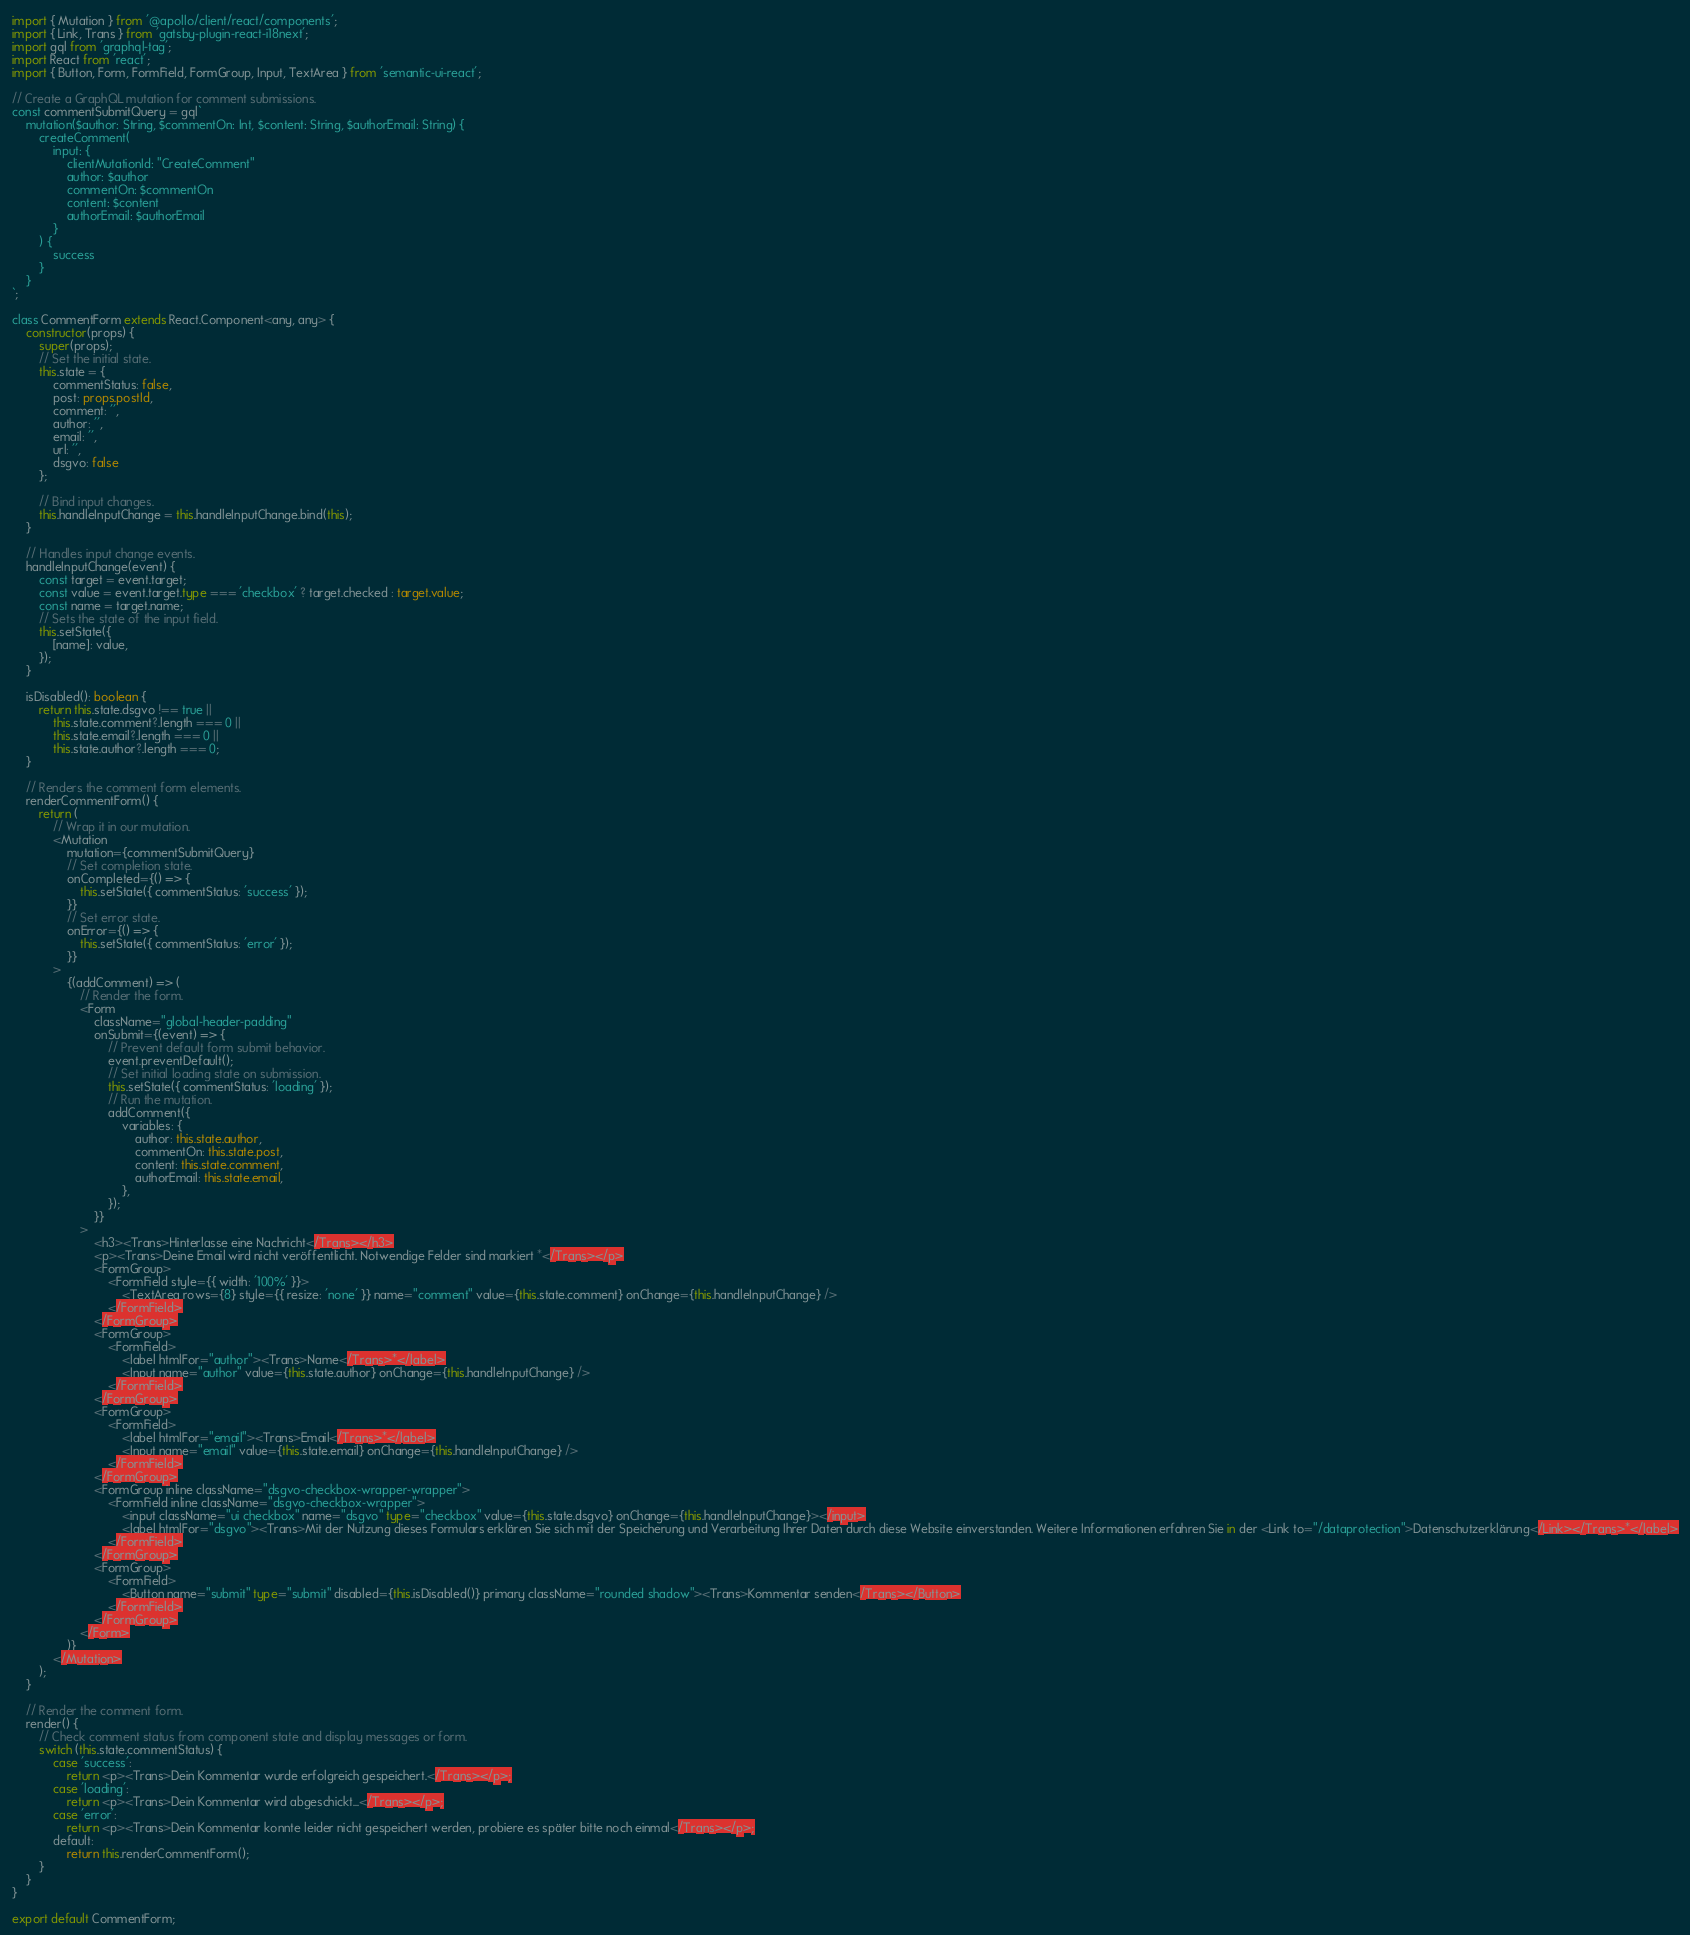Convert code to text. <code><loc_0><loc_0><loc_500><loc_500><_TypeScript_>import { Mutation } from '@apollo/client/react/components';
import { Link, Trans } from 'gatsby-plugin-react-i18next';
import gql from 'graphql-tag';
import React from 'react';
import { Button, Form, FormField, FormGroup, Input, TextArea } from 'semantic-ui-react';

// Create a GraphQL mutation for comment submissions.
const commentSubmitQuery = gql`
	mutation($author: String, $commentOn: Int, $content: String, $authorEmail: String) {
		createComment(
			input: {
				clientMutationId: "CreateComment"
				author: $author
				commentOn: $commentOn
				content: $content
				authorEmail: $authorEmail
			}
		) {
			success
		}
	}
`;

class CommentForm extends React.Component<any, any> {
	constructor(props) {
		super(props);
		// Set the initial state.
		this.state = {
			commentStatus: false,
			post: props.postId,
			comment: '',
			author: '',
			email: '',
			url: '',
			dsgvo: false
		};

		// Bind input changes.
		this.handleInputChange = this.handleInputChange.bind(this);
	}

	// Handles input change events.
	handleInputChange(event) {
		const target = event.target;
		const value = event.target.type === 'checkbox' ? target.checked : target.value;
		const name = target.name;
		// Sets the state of the input field.
		this.setState({
			[name]: value,
		});
	}

	isDisabled(): boolean {
		return this.state.dsgvo !== true ||
			this.state.comment?.length === 0 ||
			this.state.email?.length === 0 ||
			this.state.author?.length === 0;
	}

	// Renders the comment form elements.
	renderCommentForm() {
		return (
			// Wrap it in our mutation.
			<Mutation
				mutation={commentSubmitQuery}
				// Set completion state.
				onCompleted={() => {
					this.setState({ commentStatus: 'success' });
				}}
				// Set error state.
				onError={() => {
					this.setState({ commentStatus: 'error' });
				}}
			>
				{(addComment) => (
					// Render the form.
					<Form
						className="global-header-padding"
						onSubmit={(event) => {
							// Prevent default form submit behavior.
							event.preventDefault();
							// Set initial loading state on submission.
							this.setState({ commentStatus: 'loading' });
							// Run the mutation.
							addComment({
								variables: {
									author: this.state.author,
									commentOn: this.state.post,
									content: this.state.comment,
									authorEmail: this.state.email,
								},
							});
						}}
					>
						<h3><Trans>Hinterlasse eine Nachricht</Trans></h3>
						<p><Trans>Deine Email wird nicht veröffentlicht. Notwendige Felder sind markiert *</Trans></p>
						<FormGroup>
							<FormField style={{ width: '100%' }}>
								<TextArea rows={8} style={{ resize: 'none' }} name="comment" value={this.state.comment} onChange={this.handleInputChange} />
							</FormField>
						</FormGroup>
						<FormGroup>
							<FormField>
								<label htmlFor="author"><Trans>Name</Trans>*</label>
								<Input name="author" value={this.state.author} onChange={this.handleInputChange} />
							</FormField>
						</FormGroup>
						<FormGroup>
							<FormField>
								<label htmlFor="email"><Trans>Email</Trans>*</label>
								<Input name="email" value={this.state.email} onChange={this.handleInputChange} />
							</FormField>
						</FormGroup>
						<FormGroup inline className="dsgvo-checkbox-wrapper-wrapper">
							<FormField inline className="dsgvo-checkbox-wrapper">
								<input className="ui checkbox" name="dsgvo" type="checkbox" value={this.state.dsgvo} onChange={this.handleInputChange}></input>
								<label htmlFor="dsgvo"><Trans>Mit der Nutzung dieses Formulars erklären Sie sich mit der Speicherung und Verarbeitung Ihrer Daten durch diese Website einverstanden. Weitere Informationen erfahren Sie in der <Link to="/dataprotection">Datenschutzerklärung</Link></Trans>*</label>
							</FormField>
						</FormGroup>
						<FormGroup>
							<FormField>
								<Button name="submit" type="submit" disabled={this.isDisabled()} primary className="rounded shadow"><Trans>Kommentar senden</Trans></Button>
							</FormField>
						</FormGroup>
					</Form>
				)}
			</Mutation>
		);
	}

	// Render the comment form.
	render() {
		// Check comment status from component state and display messages or form.
		switch (this.state.commentStatus) {
			case 'success':
				return <p><Trans>Dein Kommentar wurde erfolgreich gespeichert.</Trans></p>;
			case 'loading':
				return <p><Trans>Dein Kommentar wird abgeschickt...</Trans></p>;
			case 'error':
				return <p><Trans>Dein Kommentar konnte leider nicht gespeichert werden, probiere es später bitte noch einmal</Trans></p>;
			default:
				return this.renderCommentForm();
		}
	}
}

export default CommentForm;</code> 